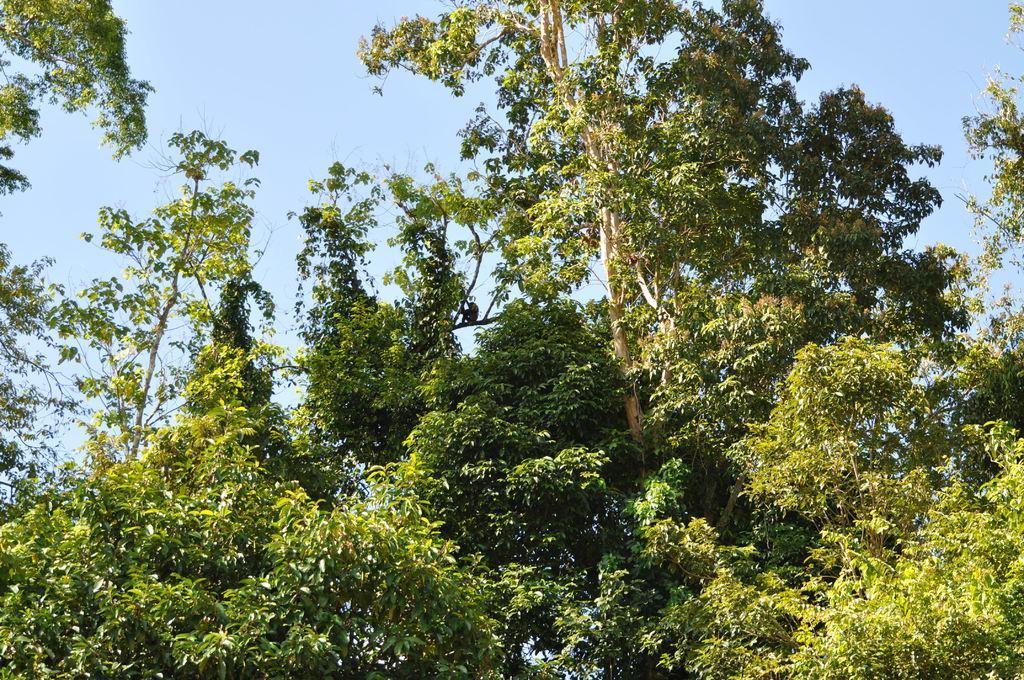Can you describe this image briefly? In this image we can see trees and sky in the background. 